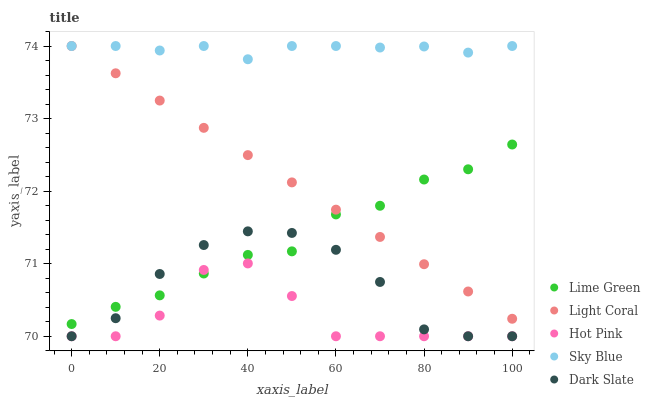Does Hot Pink have the minimum area under the curve?
Answer yes or no. Yes. Does Sky Blue have the maximum area under the curve?
Answer yes or no. Yes. Does Sky Blue have the minimum area under the curve?
Answer yes or no. No. Does Hot Pink have the maximum area under the curve?
Answer yes or no. No. Is Light Coral the smoothest?
Answer yes or no. Yes. Is Hot Pink the roughest?
Answer yes or no. Yes. Is Sky Blue the smoothest?
Answer yes or no. No. Is Sky Blue the roughest?
Answer yes or no. No. Does Hot Pink have the lowest value?
Answer yes or no. Yes. Does Sky Blue have the lowest value?
Answer yes or no. No. Does Sky Blue have the highest value?
Answer yes or no. Yes. Does Hot Pink have the highest value?
Answer yes or no. No. Is Lime Green less than Sky Blue?
Answer yes or no. Yes. Is Sky Blue greater than Hot Pink?
Answer yes or no. Yes. Does Dark Slate intersect Hot Pink?
Answer yes or no. Yes. Is Dark Slate less than Hot Pink?
Answer yes or no. No. Is Dark Slate greater than Hot Pink?
Answer yes or no. No. Does Lime Green intersect Sky Blue?
Answer yes or no. No. 